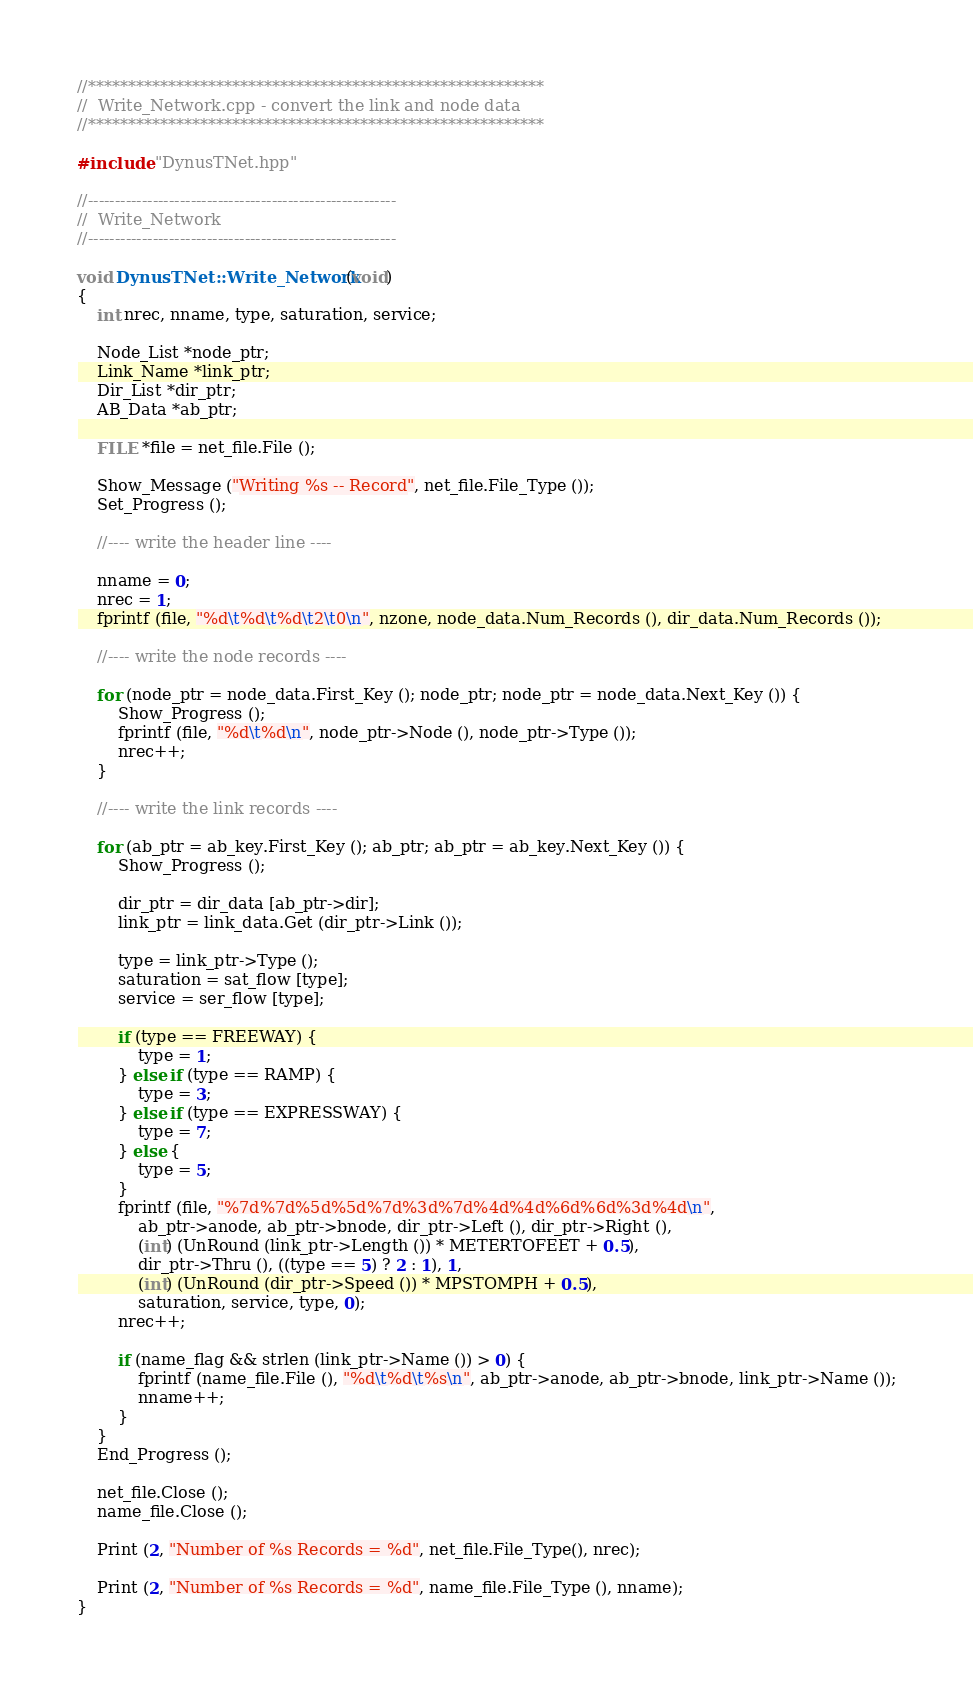Convert code to text. <code><loc_0><loc_0><loc_500><loc_500><_C++_>//*********************************************************
//	Write_Network.cpp - convert the link and node data
//*********************************************************

#include "DynusTNet.hpp"

//---------------------------------------------------------
//	Write_Network
//---------------------------------------------------------

void DynusTNet::Write_Network (void)
{
	int nrec, nname, type, saturation, service;

	Node_List *node_ptr;
	Link_Name *link_ptr;
	Dir_List *dir_ptr;
	AB_Data *ab_ptr;

	FILE *file = net_file.File ();

	Show_Message ("Writing %s -- Record", net_file.File_Type ());
	Set_Progress ();

	//---- write the header line ----

	nname = 0;
	nrec = 1;
	fprintf (file, "%d\t%d\t%d\t2\t0\n", nzone, node_data.Num_Records (), dir_data.Num_Records ());

	//---- write the node records ----

	for (node_ptr = node_data.First_Key (); node_ptr; node_ptr = node_data.Next_Key ()) {
		Show_Progress ();
		fprintf (file, "%d\t%d\n", node_ptr->Node (), node_ptr->Type ());
		nrec++;
	}

	//---- write the link records ----

	for (ab_ptr = ab_key.First_Key (); ab_ptr; ab_ptr = ab_key.Next_Key ()) {
		Show_Progress ();

		dir_ptr = dir_data [ab_ptr->dir];
		link_ptr = link_data.Get (dir_ptr->Link ());

		type = link_ptr->Type ();
		saturation = sat_flow [type];
		service = ser_flow [type];

		if (type == FREEWAY) {
			type = 1;
		} else if (type == RAMP) {
			type = 3;
		} else if (type == EXPRESSWAY) {
			type = 7;
		} else {
			type = 5;
		}
		fprintf (file, "%7d%7d%5d%5d%7d%3d%7d%4d%4d%6d%6d%3d%4d\n", 
			ab_ptr->anode, ab_ptr->bnode, dir_ptr->Left (), dir_ptr->Right (),
			(int) (UnRound (link_ptr->Length ()) * METERTOFEET + 0.5),
			dir_ptr->Thru (), ((type == 5) ? 2 : 1), 1, 
			(int) (UnRound (dir_ptr->Speed ()) * MPSTOMPH + 0.5),
			saturation, service, type, 0);
		nrec++;

		if (name_flag && strlen (link_ptr->Name ()) > 0) {
			fprintf (name_file.File (), "%d\t%d\t%s\n", ab_ptr->anode, ab_ptr->bnode, link_ptr->Name ());
			nname++;
		}
	}
	End_Progress ();

	net_file.Close ();
	name_file.Close ();

	Print (2, "Number of %s Records = %d", net_file.File_Type(), nrec);
	
	Print (2, "Number of %s Records = %d", name_file.File_Type (), nname);
}
</code> 